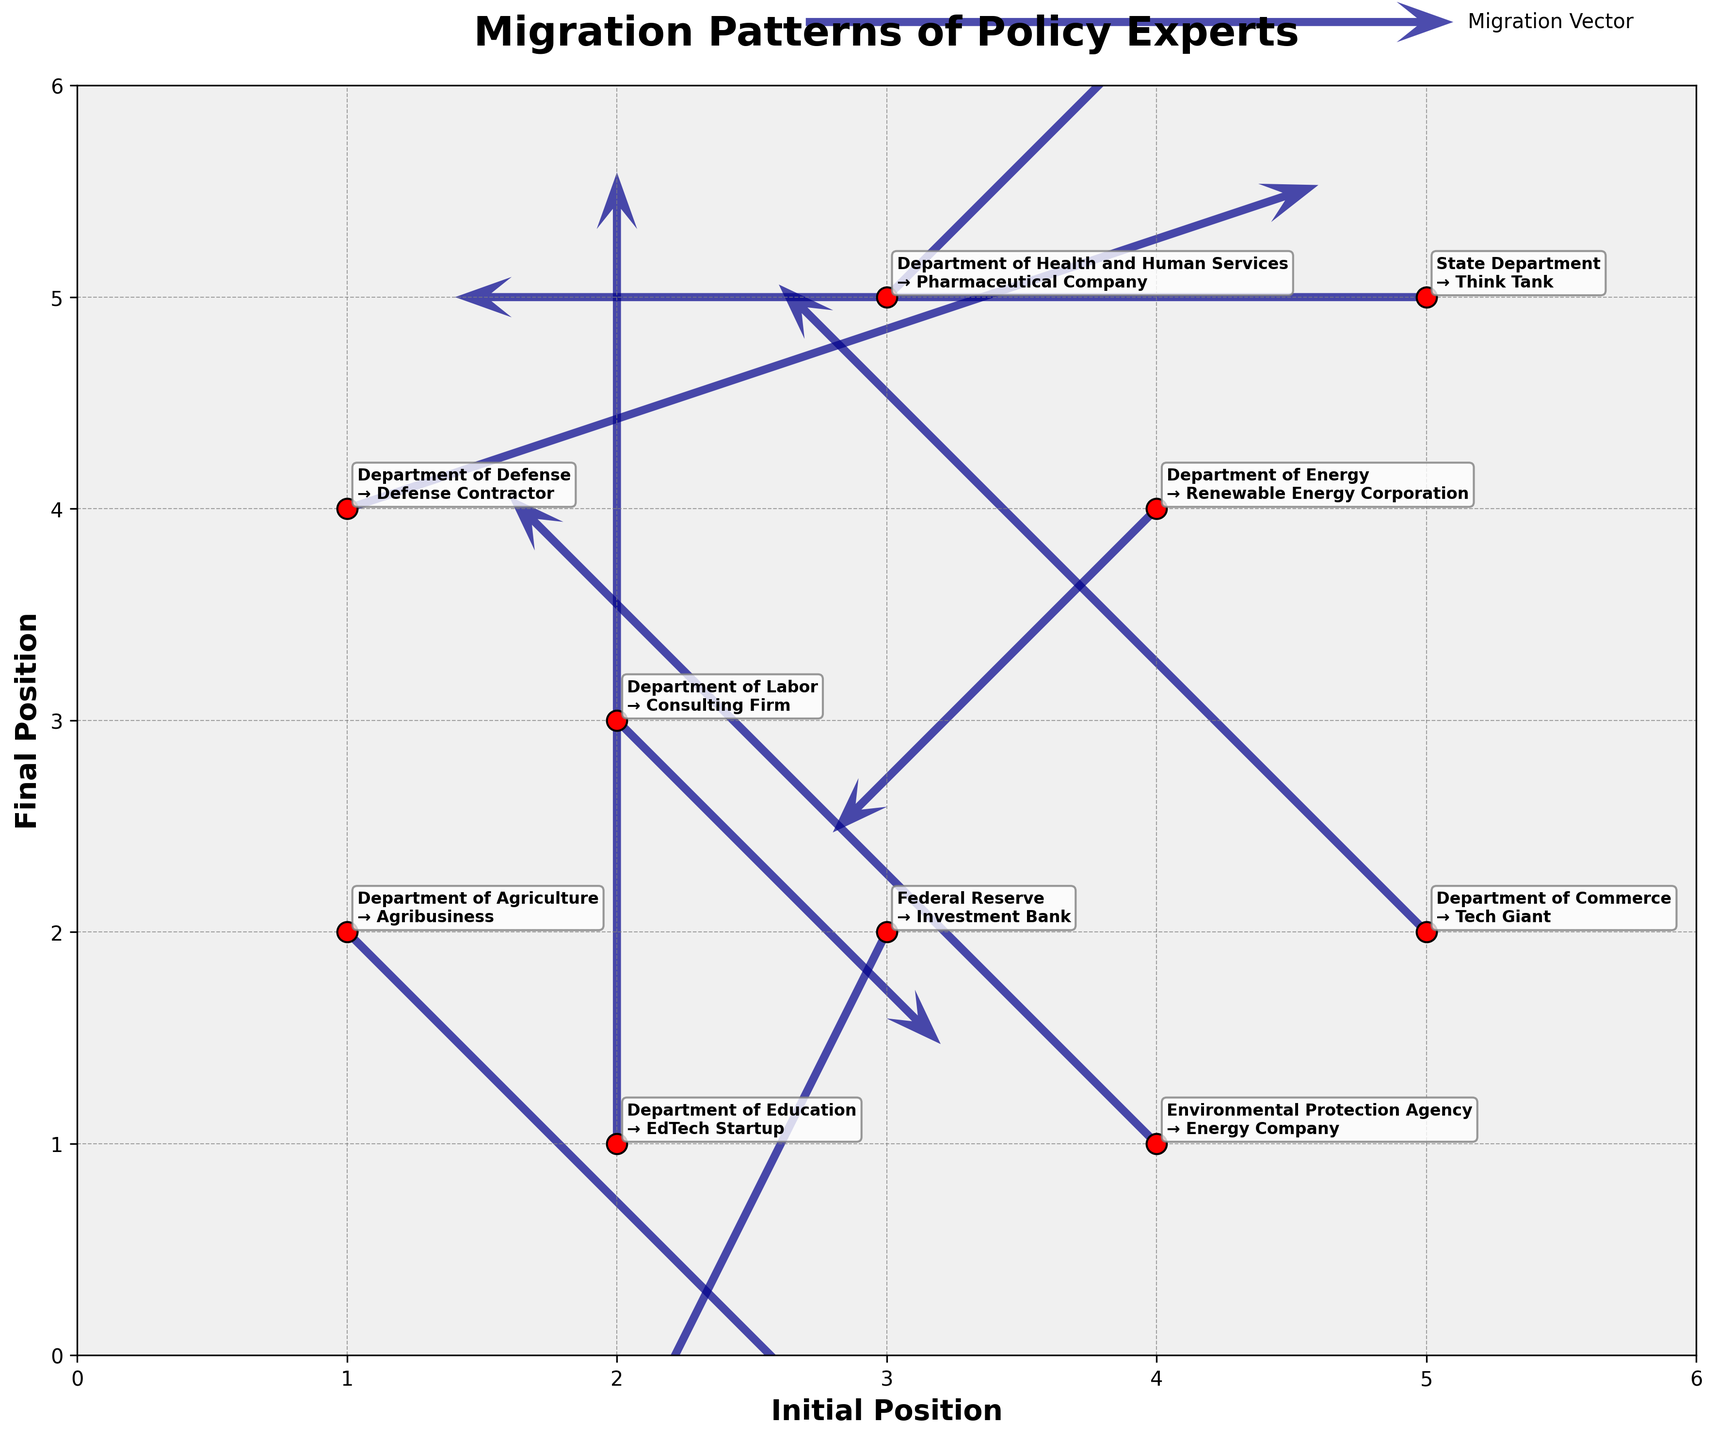What is the title of the plot? The title of the plot is displayed at the top in a bold and larger font compared to other texts in the figure, reading "Migration Patterns of Policy Experts".
Answer: Migration Patterns of Policy Experts How many data points are displayed in the quiver plot? By counting the number of red scatter points in the plot, we see there are 10 data points in total.
Answer: 10 Which agency's policy experts move towards an Investment Bank? By looking at the annotations near the arrows, it indicates that policy experts from the Federal Reserve migrate towards an Investment Bank.
Answer: Federal Reserve What is the color used for the migration vectors? The migration vectors are displayed in a dark blue color, which contrasts clearly against the background and scatter points.
Answer: Dark blue How many arrows show a net upward movement (positive v component)? By checking the v values in the annotations or arrows' directions, we find 4 arrows with a positive v component from the Environmental Protection Agency, Department of Education, Department of Defense, and Department of Commerce.
Answer: 4 Which agency has the longest horizontal migration (largest or smallest u component)? The figure shows numerical values for each vector; the Department of Defense has the largest positive horizontal movement (u=3), and the State Department has the largest negative horizontal movement (u=-3). Both are equally long but in opposite directions.
Answer: Department of Defense and State Department What is the shortest vector shown in the plot? The shortest vector has the smallest combined magnitude of (u, v). The smallest values are from the State Department with a vector of (-3, 0).
Answer: State Department Which agency's policy experts move directly downward? A direct downward movement would have a negative v and zero u. According to the annotations, experts from the Department of Energy move directly downward with values (-1, -1).
Answer: Department of Energy Which sector attracts a policy expert starting at (2,1)? Check the point at coordinates (2,1) and its corresponding arrow; experts from the Department of Education move to the EdTech Startup.
Answer: EdTech Startup 